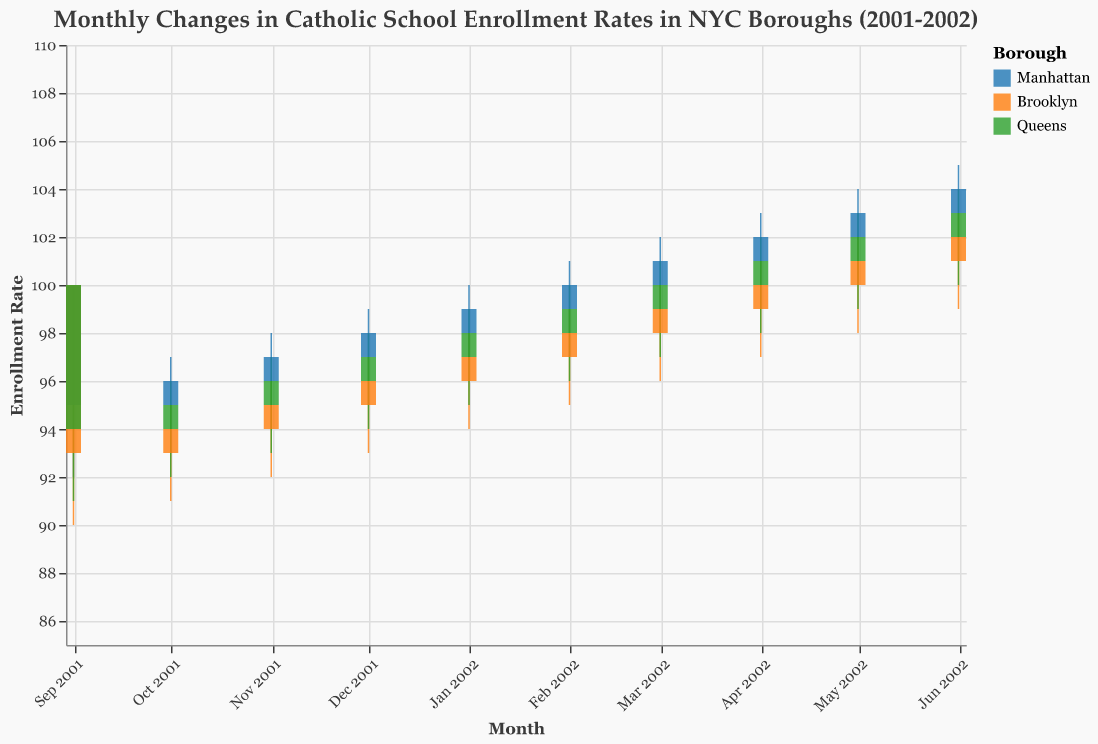what is the title of the figure? The title of the figure is written at the top of the chart.
Answer: Monthly Changes in Catholic School Enrollment Rates in NYC Boroughs (2001-2002) In which borough did the enrollment rate reach the lowest in September 2001? The figure indicates that the Low value in September 2001 is lowest at 90 for Brooklyn.
Answer: Brooklyn How many times did the enrollment rate close higher in Manhattan compared to Brooklyn between September 2001 and June 2002? By examining the Close values for both boroughs in each month, Manhattan has a higher Close value compared to Brooklyn every month during the time frame, a total of 10 times.
Answer: 10 times Which borough showed the highest enrollment rate in June 2002? The figure shows the High values for all boroughs in June 2002, with Manhattan reaching the highest value at 105.
Answer: Manhattan What was the enrollment rate close value in Queens in May 2002? Looking at the Close value in May 2002 for Queens, it is given as 102.
Answer: 102 What is the average close enrollment rate in Manhattan from September 2001 to December 2001? The Close values in Manhattan from September to December 2001 are 95, 96, 97, and 98 respectively. The average is (95 + 96 + 97 + 98) / 4 = 96.5.
Answer: 96.5 Which borough had the highest increase in the closing enrollment rate from September 2001 to June 2002? To find this, we look at the difference between the Close values for September 2001 and June 2002 for each borough. Manhattan: 104 - 95 = 9, Brooklyn: 102 - 93 = 9, Queens: 103 - 94 = 9. All boroughs had the same highest increase of 9.
Answer: Manhattan, Brooklyn, Queens Comparing April 2002, which borough had the higher high value and what was the value? Look at the High value for each borough in April 2002. Manhattan has a High of 103, Brooklyn has 101, and Queens has 102. Manhattan has the highest High value.
Answer: Manhattan, 103 What trend can be observed in the enrollment rate for Manhattan from January 2002 to June 2002? Observing the Open, High, Low, and Close values from January to June 2002 in Manhattan, it shows a consistent upward trend in the enrollment rate.
Answer: Upward trend Which borough exhibited the least volatility in their enrollment rates during the entire period? Volatility can be assessed by looking at the range (High - Low) for each month and the fluctuations over the period. By visually examining the ranges, Queens appears to have the least volatility with close and more consistent ranges.
Answer: Queens 